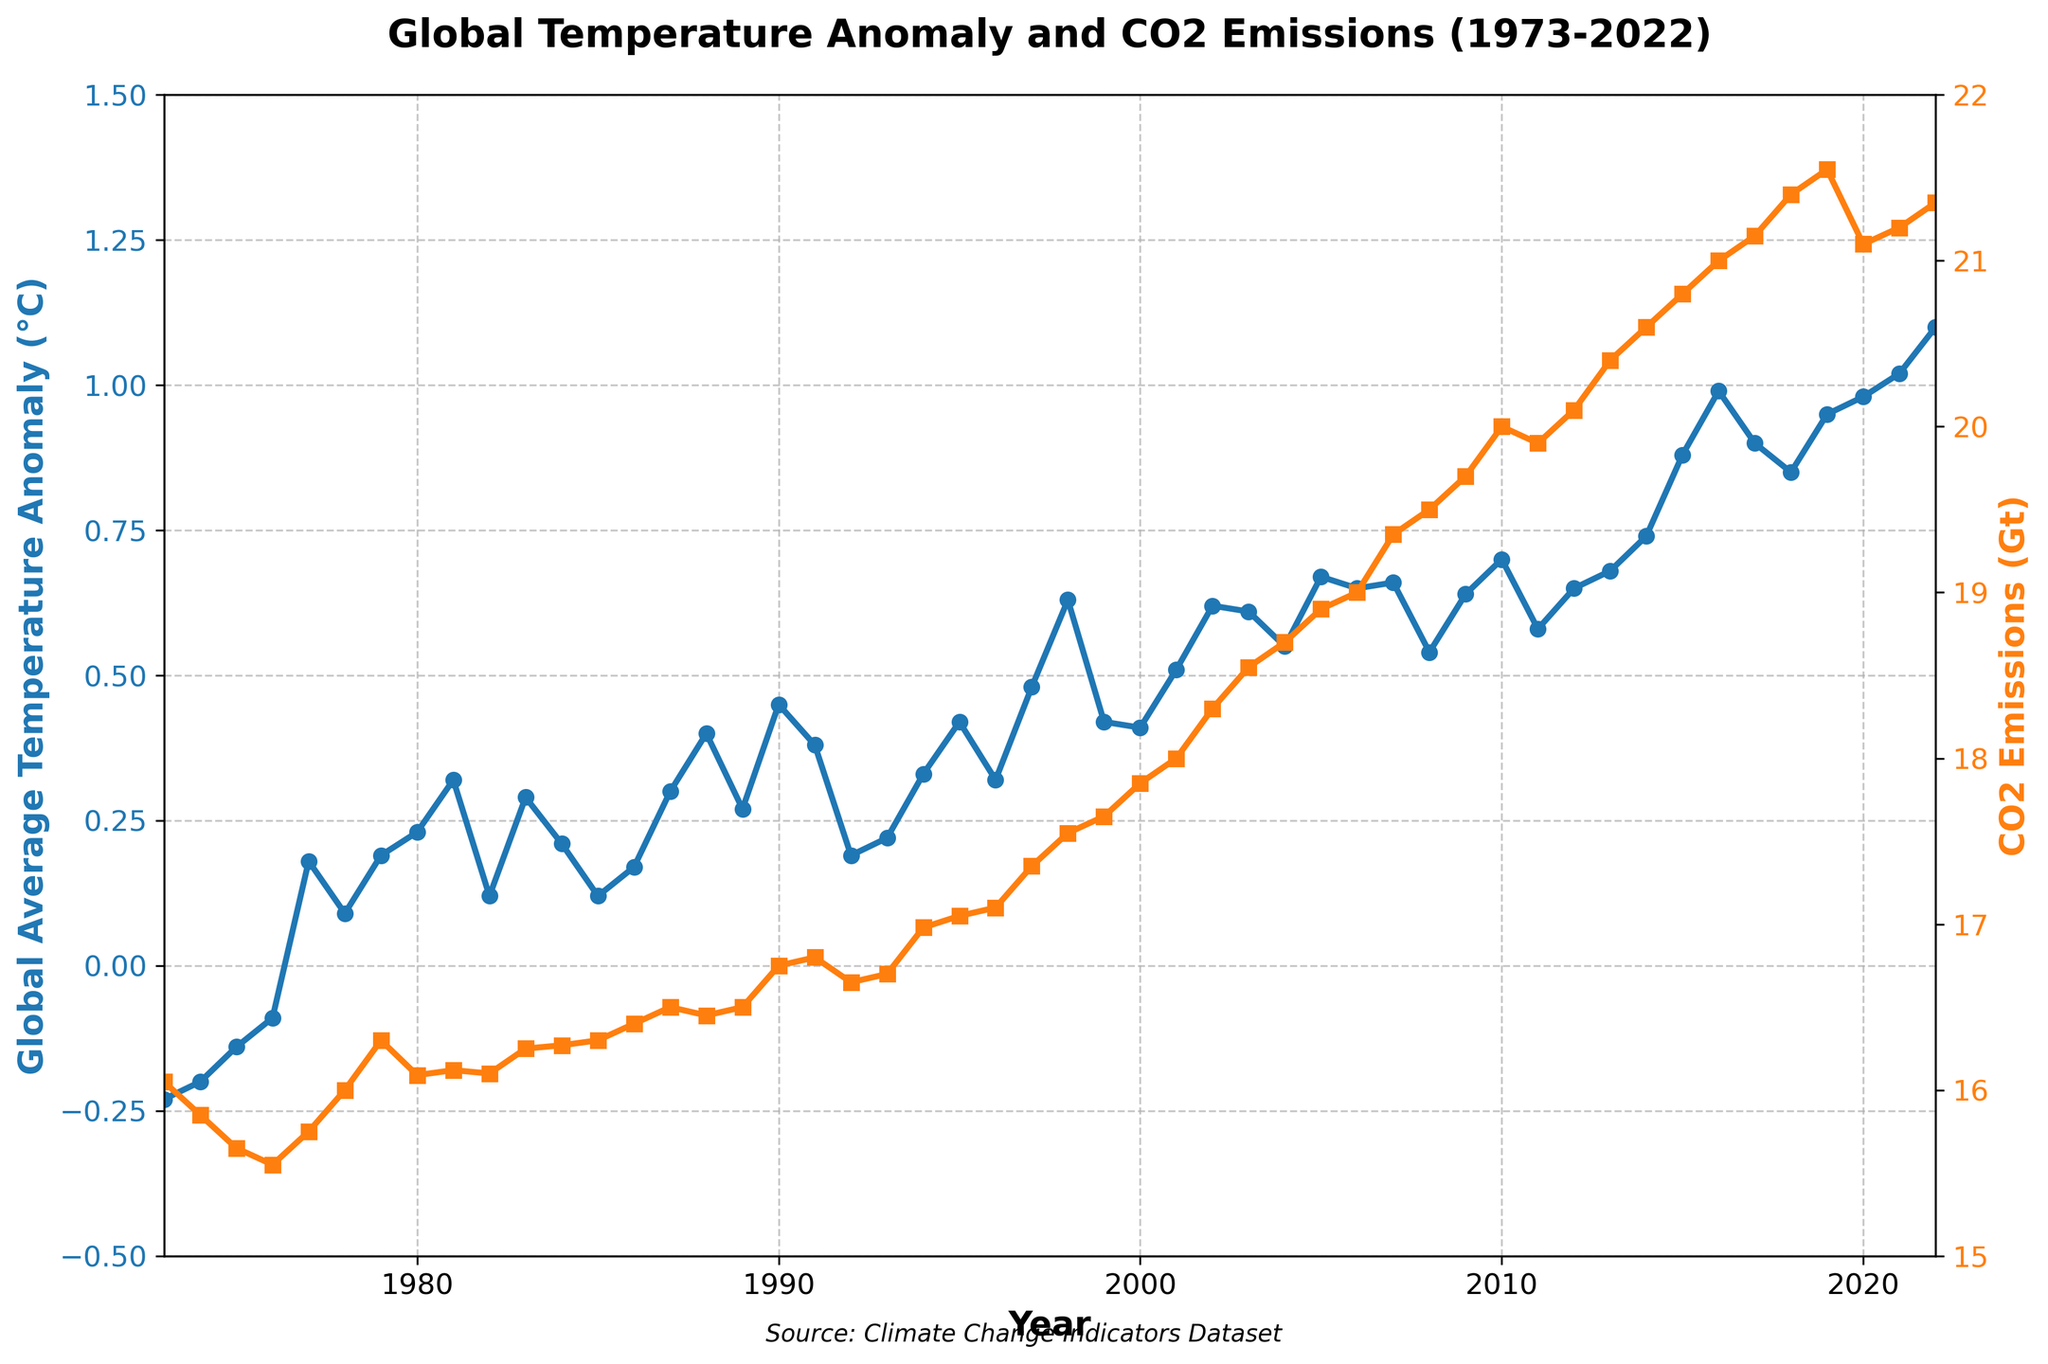What is the title of the figure? The title is prominently displayed at the top of the plot usually. Reading the text at the top center, the title should be directly visible.
Answer: Global Temperature Anomaly and CO2 Emissions (1973-2022) What is the color of the line representing Global Average Temperature Anomaly? The color of the line representing Global Average Temperature Anomaly is observed in the plot. It uses a specific color to distinguish it from CO2 Emissions.
Answer: Blue What is the highest value of CO2 emissions during the period shown in the plot? To find the highest value, trace the CO2 Emissions line and identify the peak value on the y-axis labeled for CO2 Emissions.
Answer: 21.55 Gt In which year did the Global Average Temperature Anomaly reach 0.99°C? Find the data point on the Global Average Temperature Anomaly line that reaches 0.99°C, then check the corresponding year on the x-axis.
Answer: 2016 What was the CO2 emission level in the year 2000? Locate the year 2000 on the x-axis, then trace vertically to the CO2 Emissions line to read the value on the right y-axis.
Answer: 17.85 Gt Which year saw a larger increase in Global Average Temperature Anomaly compared to the previous year: 2001 to 2002, or 2014 to 2015? Calculate the difference in temperature anomaly for both year pairs: (2002 - 2001) and (2015 - 2014). Compare the two differences to determine which is larger.
Answer: 2014 to 2015 What's the average Global Average Temperature Anomaly between 2010 and 2015? Sum the temperature anomalies from 2010 to 2015 and divide by the number of years (6). (0.70 + 0.58 + 0.65 + 0.68 + 0.74 + 0.88) / 6 = 0.705°C.
Answer: 0.705°C Which year had a higher Global Average Temperature Anomaly rate: 1988 or 1990? Compare the values of Global Average Temperature Anomaly in 1988 and 1990 directly from the plot.
Answer: 1990 How did the trend of CO2 emissions change after 2010? Observe the general direction of the CO2 Emissions line post-2010 to determine if it was increasing, decreasing, or stable.
Answer: Increasing What was the Global Average Temperature Anomaly in the coldest recorded year? Identify the lowest point on the Global Average Temperature Anomaly line and find the year and corresponding value.
Answer: -0.23°C in 1973 